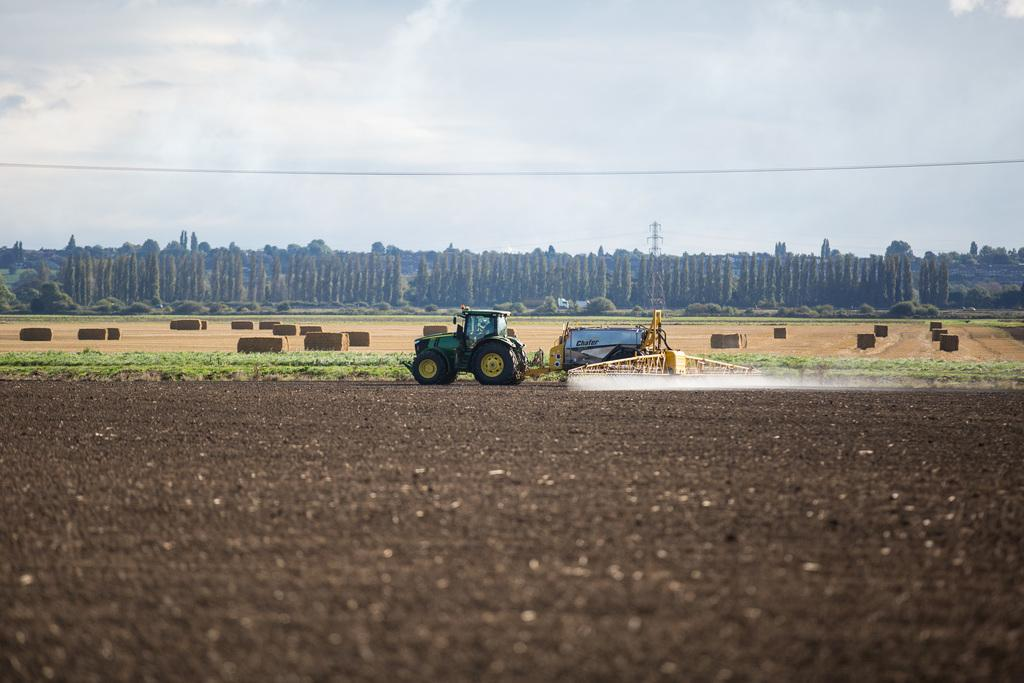What is the main subject of the image? There is a vehicle in the image. Can you describe the position of the vehicle? The vehicle is on the ground. What can be seen in the background of the image? There are trees and the sky visible in the background of the image. What type of bun is being used as a seat cushion in the image? There is no bun present in the image, and therefore no such use can be observed. 